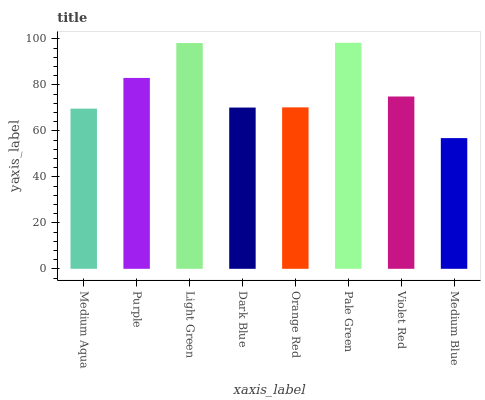Is Pale Green the maximum?
Answer yes or no. Yes. Is Purple the minimum?
Answer yes or no. No. Is Purple the maximum?
Answer yes or no. No. Is Purple greater than Medium Aqua?
Answer yes or no. Yes. Is Medium Aqua less than Purple?
Answer yes or no. Yes. Is Medium Aqua greater than Purple?
Answer yes or no. No. Is Purple less than Medium Aqua?
Answer yes or no. No. Is Violet Red the high median?
Answer yes or no. Yes. Is Orange Red the low median?
Answer yes or no. Yes. Is Pale Green the high median?
Answer yes or no. No. Is Pale Green the low median?
Answer yes or no. No. 